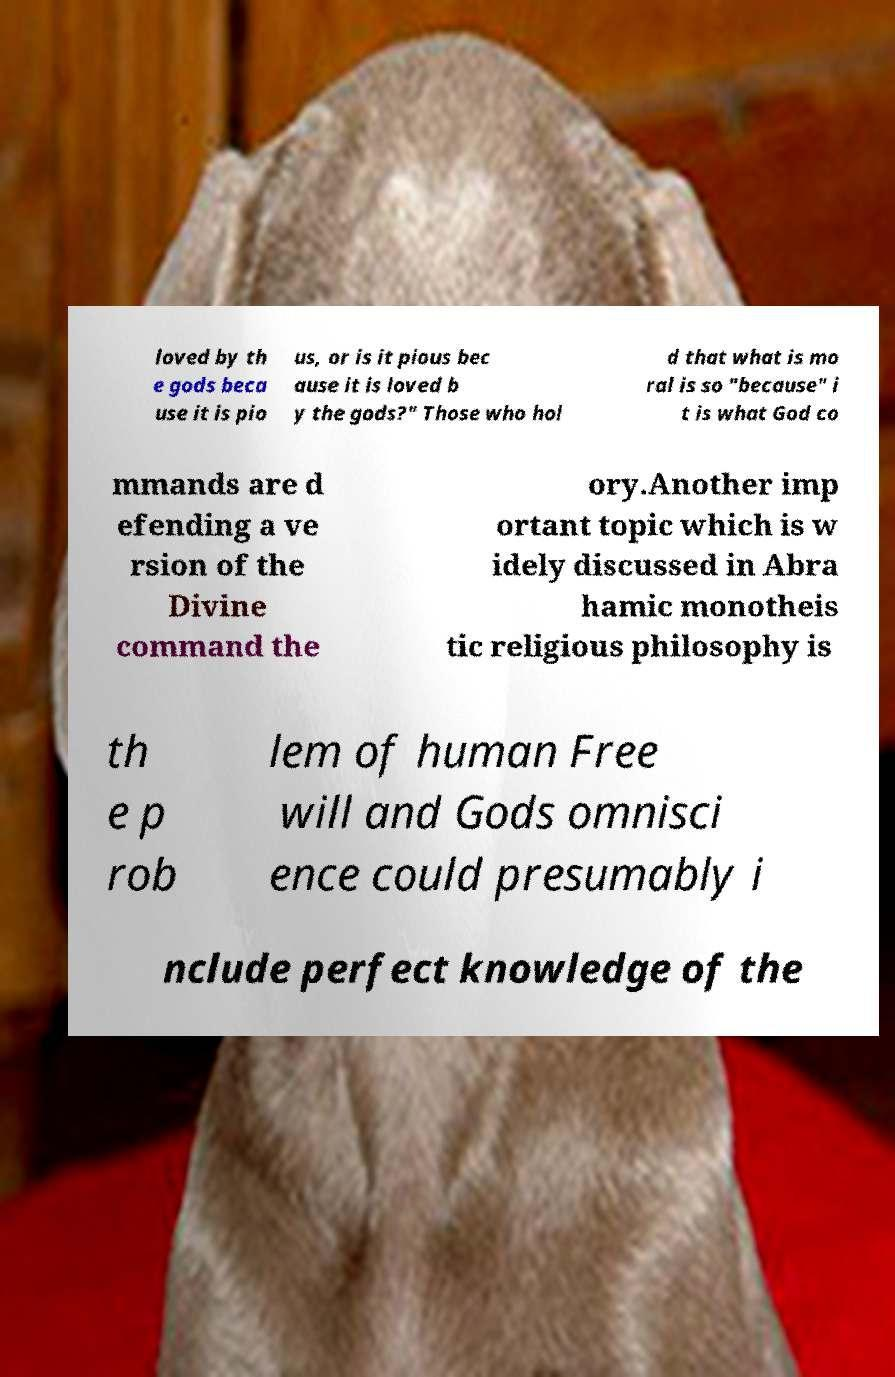Please read and relay the text visible in this image. What does it say? loved by th e gods beca use it is pio us, or is it pious bec ause it is loved b y the gods?" Those who hol d that what is mo ral is so "because" i t is what God co mmands are d efending a ve rsion of the Divine command the ory.Another imp ortant topic which is w idely discussed in Abra hamic monotheis tic religious philosophy is th e p rob lem of human Free will and Gods omnisci ence could presumably i nclude perfect knowledge of the 